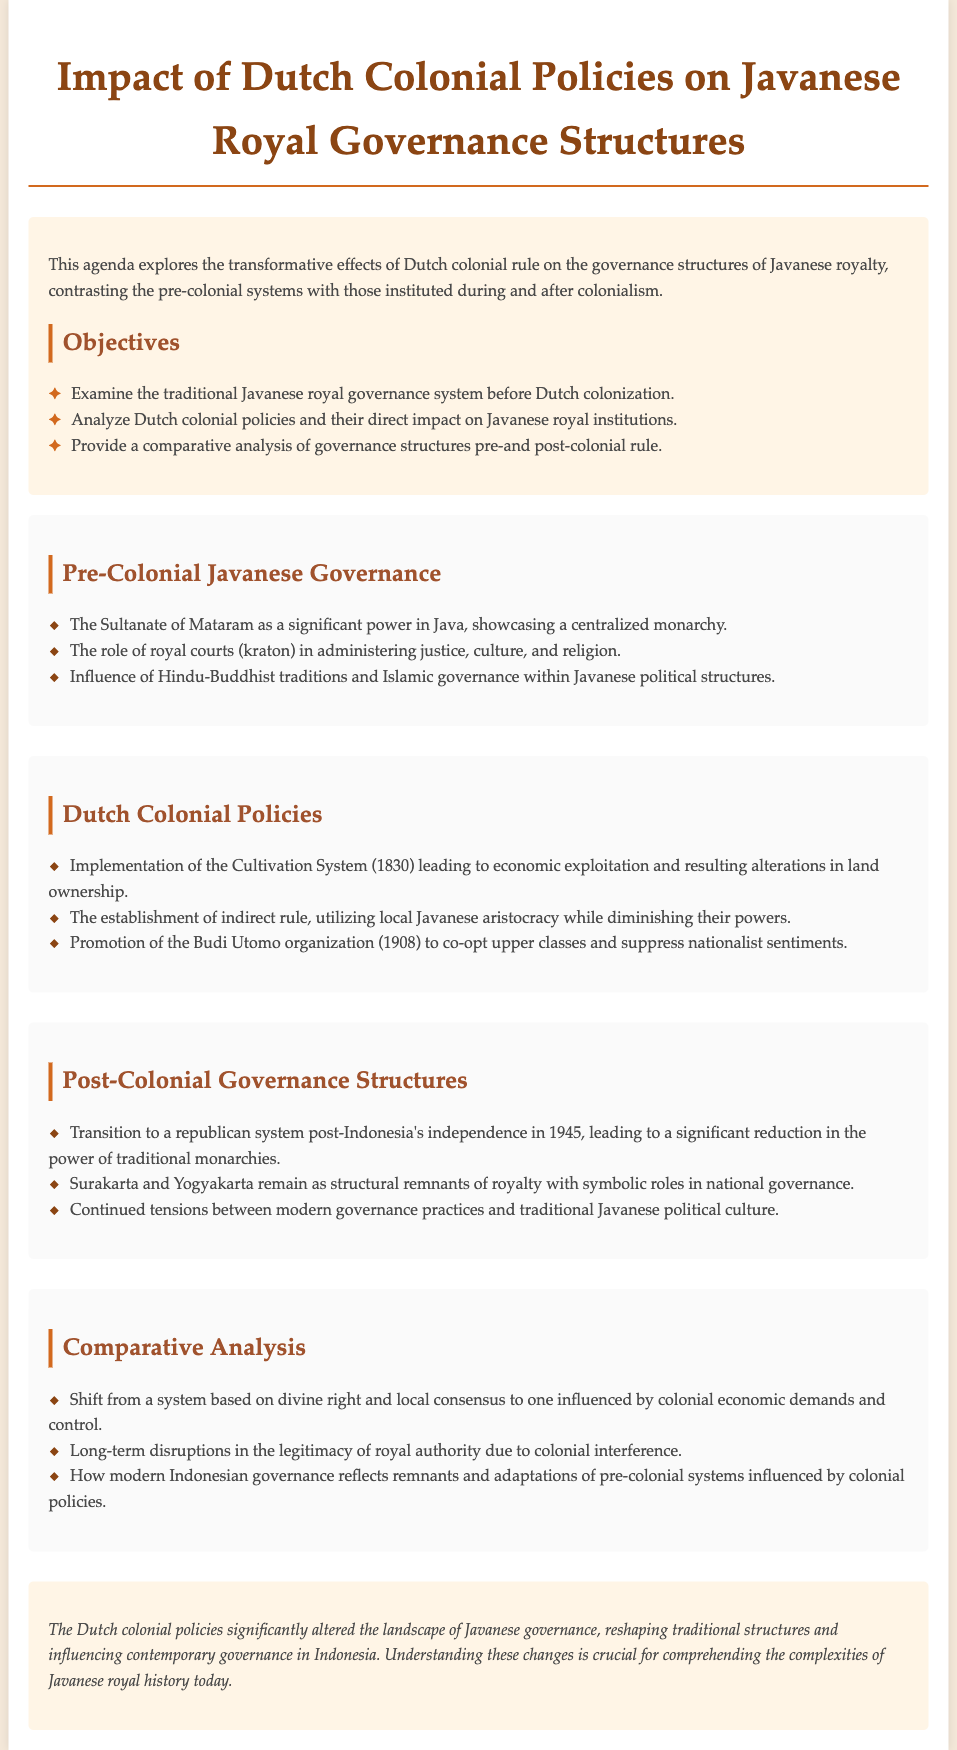What is the title of the document? The title of the document, as presented at the top, outlines the main focus and topic of discussion.
Answer: Impact of Dutch Colonial Policies on Javanese Royal Governance Structures What year was the Budi Utomo organization promoted? The document specifically mentions the date in which this organization was promoted, illustrating its historical relevance.
Answer: 1908 What significant power is referenced in the pre-colonial governance section? The section on pre-colonial governance identifies a major entity that once held authority in Java, indicating its importance in history.
Answer: Sultanate of Mataram What system was implemented in 1830? The document outlines a specific colonial policy and its timeline, which played a crucial role during the Dutch colonial era.
Answer: Cultivation System How many objectives are listed in the document? The document states the number of objectives that frame the discussions and analyses within the agenda.
Answer: Three What remains as structural remnants of royalty post-independence? This detail highlights the ongoing influence of traditional monarchies after Indonesia gained independence and indicates their current status.
Answer: Surakarta and Yogyakarta What is a key impact of colonial rule mentioned in relation to royal authority? This question addresses the significant change in legitimacy regarding royal governance as a result of Dutch interference.
Answer: Long-term disruptions What type of governance did Indonesia transition to after 1945? The document covers the drastic changes in the governance structure in Indonesia following independence, marking a shift in political systems.
Answer: Republican system What cultural influences were mentioned in the pre-colonial governance section? This question probes into the cultural aspects that shaped the governance in pre-colonial Java, reflecting the diversity of political influences.
Answer: Hindu-Buddhist traditions and Islamic governance 